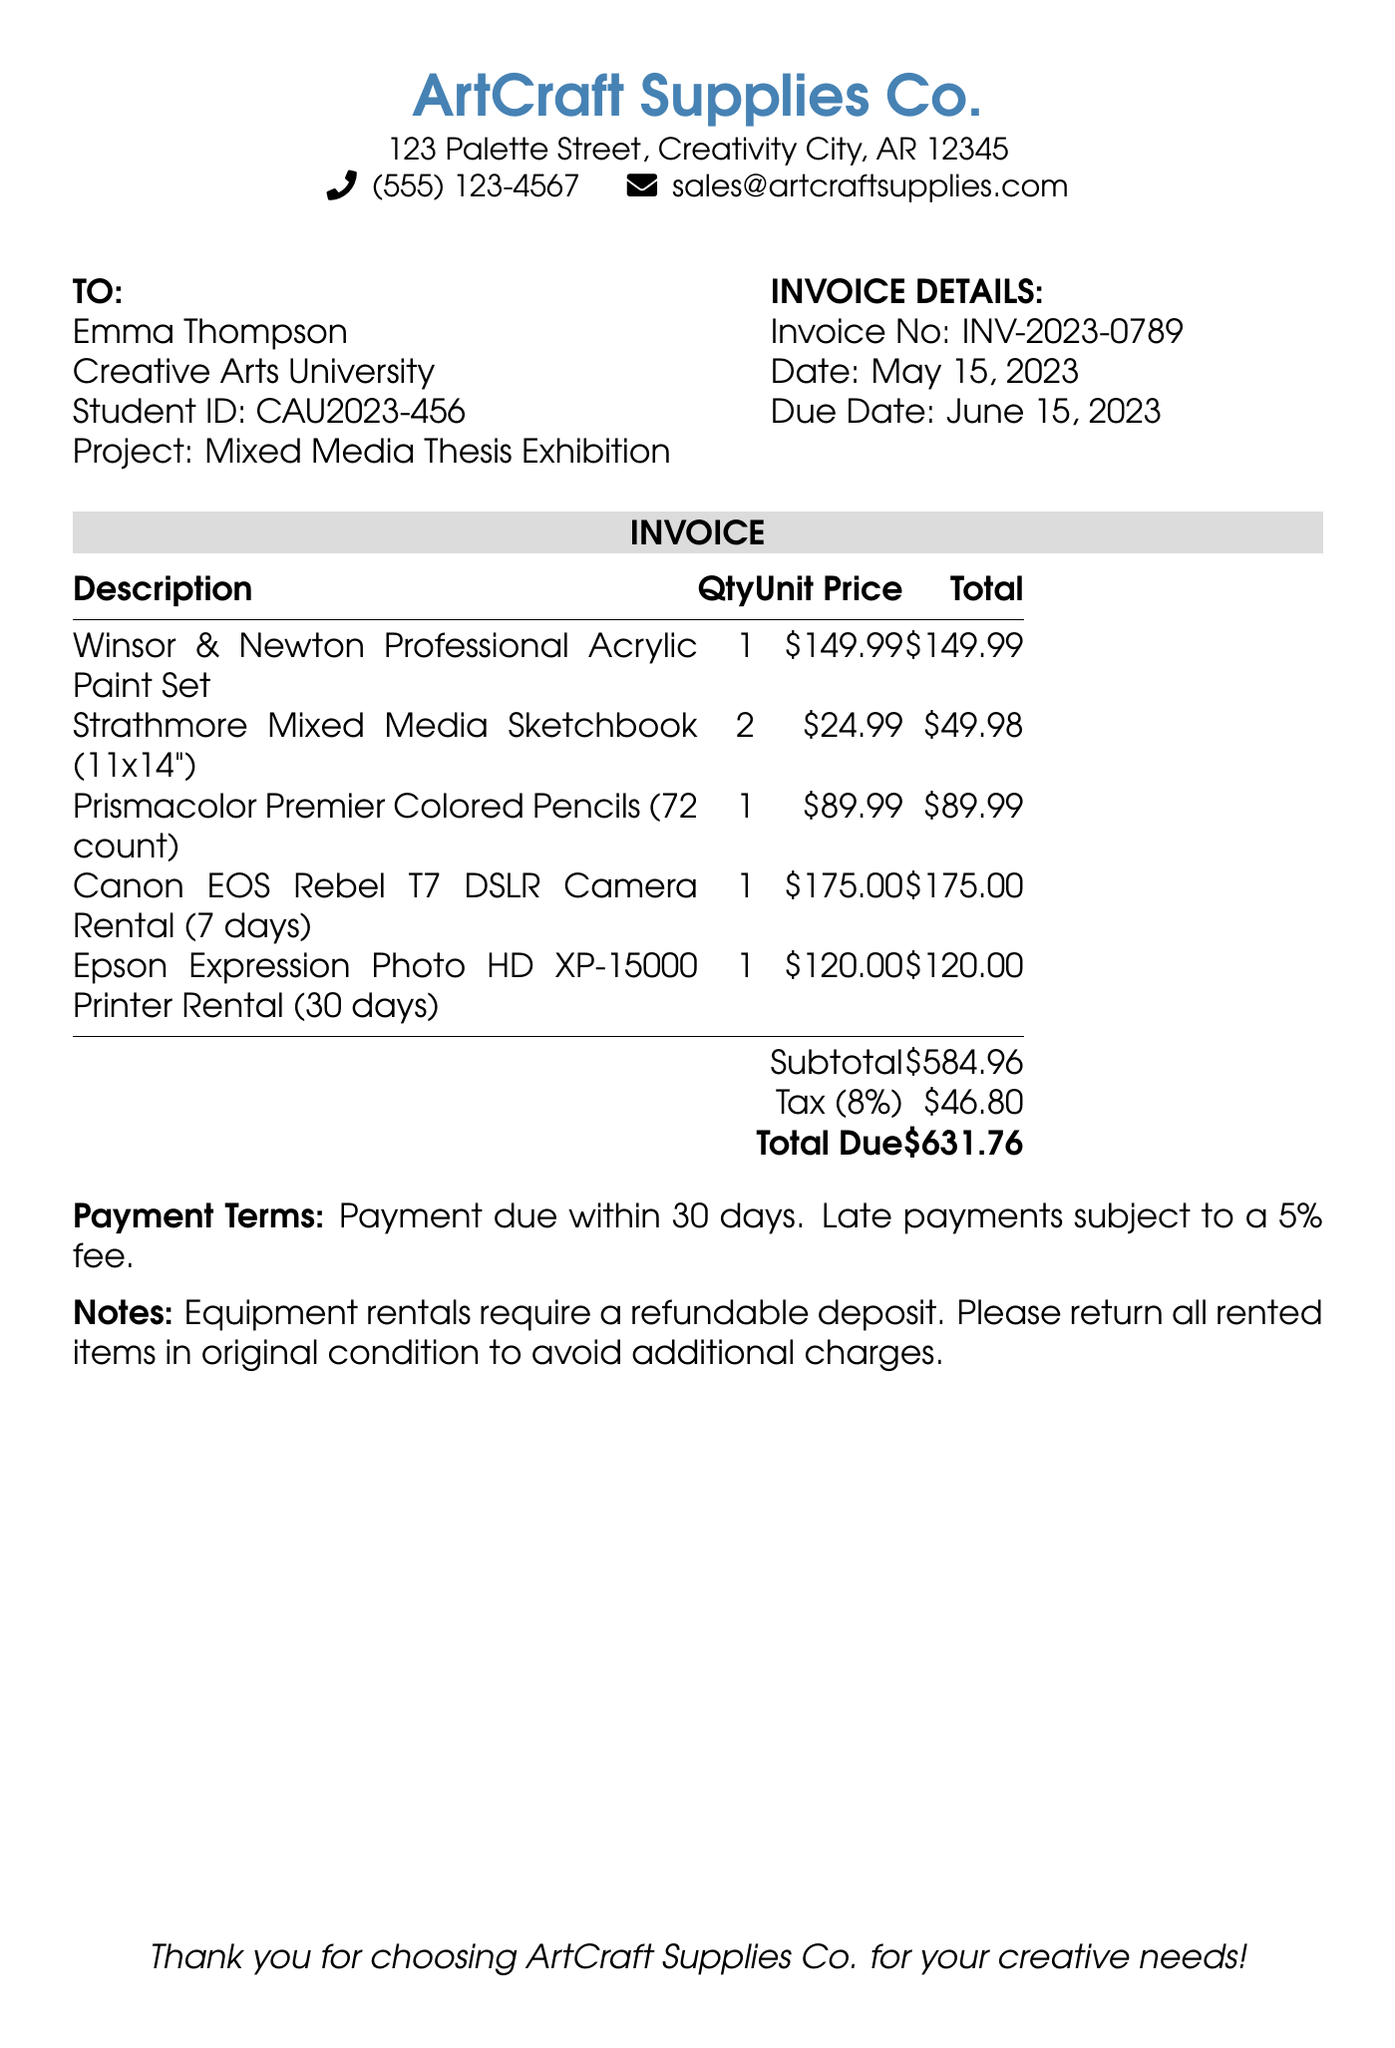What is the invoice number? The invoice number is listed in the document under "Invoice Details."
Answer: INV-2023-0789 What is the date of the invoice? The date is provided in the invoice details section.
Answer: May 15, 2023 How many items are listed in the invoice? The number of items is determined by counting the descriptions in the invoice table.
Answer: 5 What is the unit price of the Canon EOS Rebel T7 DSLR Camera Rental? The unit price can be found in the invoice table under the respective description.
Answer: $175.00 What is the subtotal amount on the invoice? The subtotal is calculated as the total of all individual item amounts listed before taxes.
Answer: $584.96 What is the due date for payment? The due date is noted in the invoice details section.
Answer: June 15, 2023 What percentage is the tax applied to the subtotal? The tax percentage is specified in the invoice.
Answer: 8% What is the total amount due? The total amount due is the sum of the subtotal and the tax amount.
Answer: $631.76 What is the payment term mentioned in the invoice? The payment terms are stated at the end of the document.
Answer: Payment due within 30 days 